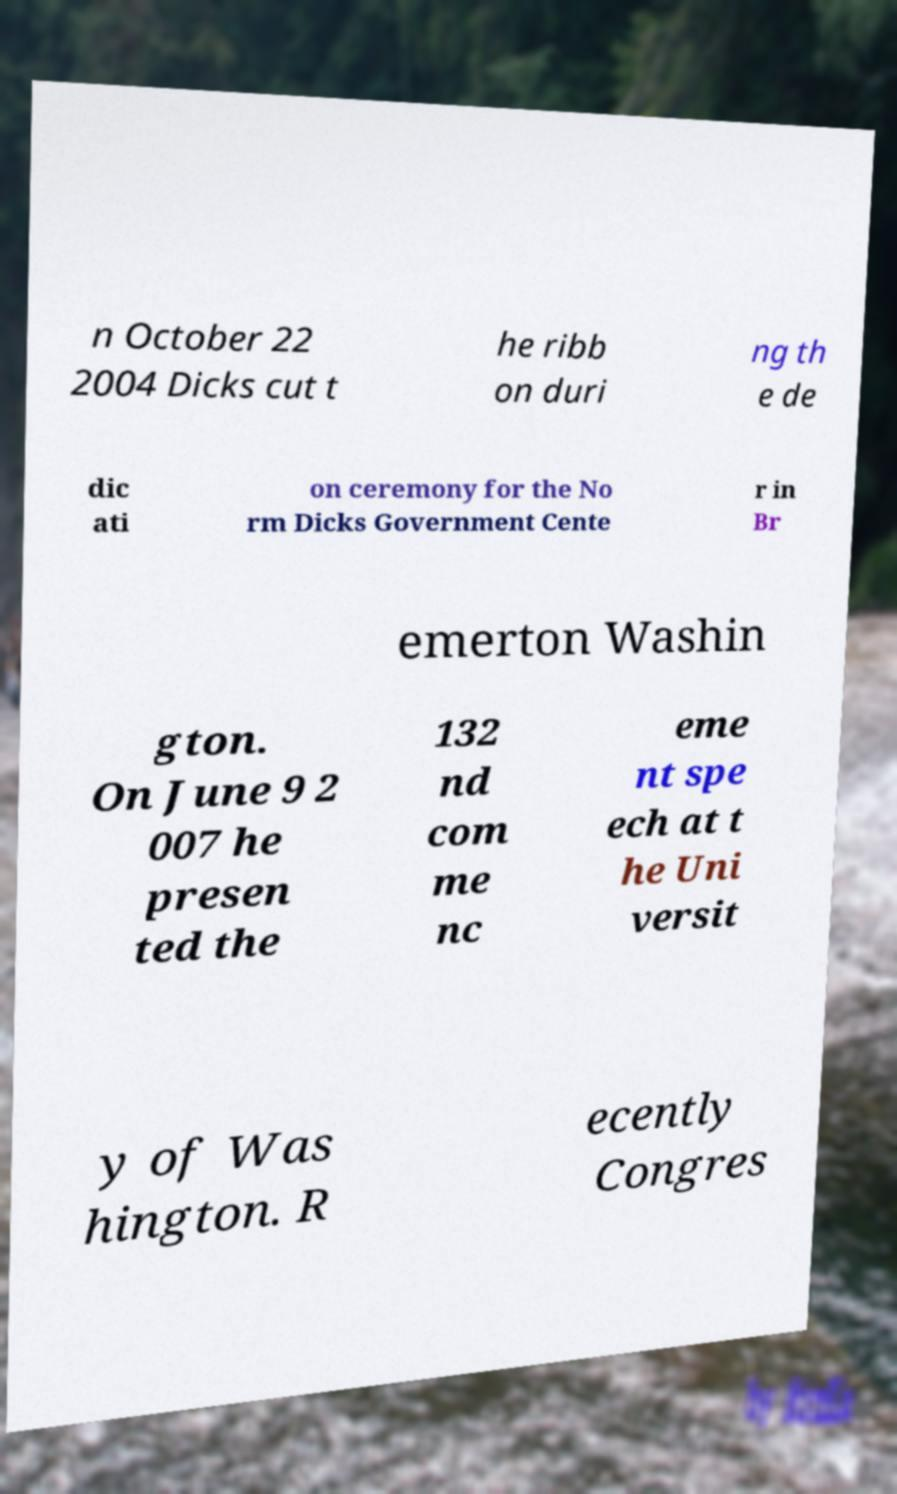Could you assist in decoding the text presented in this image and type it out clearly? n October 22 2004 Dicks cut t he ribb on duri ng th e de dic ati on ceremony for the No rm Dicks Government Cente r in Br emerton Washin gton. On June 9 2 007 he presen ted the 132 nd com me nc eme nt spe ech at t he Uni versit y of Was hington. R ecently Congres 